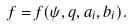<formula> <loc_0><loc_0><loc_500><loc_500>f = f ( \psi , q , a _ { i } , b _ { i } ) .</formula> 